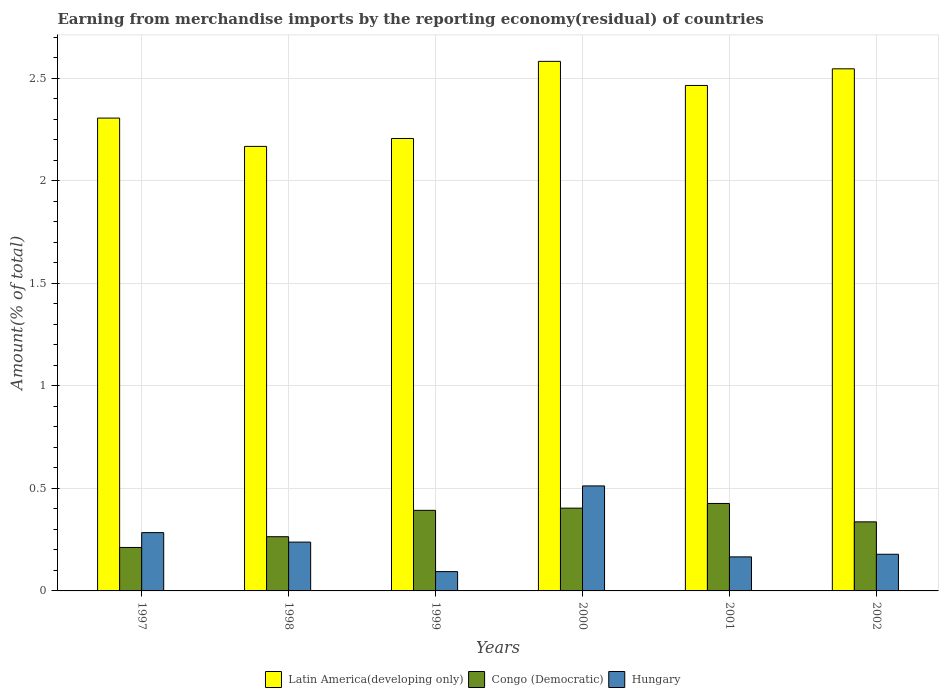How many different coloured bars are there?
Offer a very short reply. 3. How many groups of bars are there?
Make the answer very short. 6. Are the number of bars per tick equal to the number of legend labels?
Offer a very short reply. Yes. How many bars are there on the 5th tick from the left?
Your response must be concise. 3. In how many cases, is the number of bars for a given year not equal to the number of legend labels?
Your response must be concise. 0. What is the percentage of amount earned from merchandise imports in Latin America(developing only) in 1999?
Your answer should be very brief. 2.21. Across all years, what is the maximum percentage of amount earned from merchandise imports in Hungary?
Your answer should be very brief. 0.51. Across all years, what is the minimum percentage of amount earned from merchandise imports in Hungary?
Your response must be concise. 0.09. In which year was the percentage of amount earned from merchandise imports in Congo (Democratic) maximum?
Offer a terse response. 2001. What is the total percentage of amount earned from merchandise imports in Hungary in the graph?
Ensure brevity in your answer.  1.47. What is the difference between the percentage of amount earned from merchandise imports in Hungary in 1997 and that in 2000?
Provide a succinct answer. -0.23. What is the difference between the percentage of amount earned from merchandise imports in Latin America(developing only) in 2000 and the percentage of amount earned from merchandise imports in Hungary in 2001?
Your response must be concise. 2.42. What is the average percentage of amount earned from merchandise imports in Latin America(developing only) per year?
Offer a very short reply. 2.38. In the year 1998, what is the difference between the percentage of amount earned from merchandise imports in Congo (Democratic) and percentage of amount earned from merchandise imports in Hungary?
Your answer should be compact. 0.03. What is the ratio of the percentage of amount earned from merchandise imports in Congo (Democratic) in 1998 to that in 2001?
Provide a succinct answer. 0.62. What is the difference between the highest and the second highest percentage of amount earned from merchandise imports in Hungary?
Give a very brief answer. 0.23. What is the difference between the highest and the lowest percentage of amount earned from merchandise imports in Congo (Democratic)?
Offer a very short reply. 0.21. In how many years, is the percentage of amount earned from merchandise imports in Congo (Democratic) greater than the average percentage of amount earned from merchandise imports in Congo (Democratic) taken over all years?
Provide a short and direct response. 3. Is the sum of the percentage of amount earned from merchandise imports in Latin America(developing only) in 1997 and 2000 greater than the maximum percentage of amount earned from merchandise imports in Hungary across all years?
Your answer should be compact. Yes. What does the 1st bar from the left in 1999 represents?
Keep it short and to the point. Latin America(developing only). What does the 3rd bar from the right in 2001 represents?
Your answer should be compact. Latin America(developing only). How many bars are there?
Make the answer very short. 18. How many years are there in the graph?
Your answer should be very brief. 6. What is the difference between two consecutive major ticks on the Y-axis?
Make the answer very short. 0.5. Does the graph contain any zero values?
Keep it short and to the point. No. Where does the legend appear in the graph?
Your answer should be compact. Bottom center. How many legend labels are there?
Offer a terse response. 3. How are the legend labels stacked?
Your answer should be compact. Horizontal. What is the title of the graph?
Offer a very short reply. Earning from merchandise imports by the reporting economy(residual) of countries. What is the label or title of the X-axis?
Make the answer very short. Years. What is the label or title of the Y-axis?
Provide a succinct answer. Amount(% of total). What is the Amount(% of total) of Latin America(developing only) in 1997?
Offer a terse response. 2.31. What is the Amount(% of total) in Congo (Democratic) in 1997?
Provide a short and direct response. 0.21. What is the Amount(% of total) of Hungary in 1997?
Provide a succinct answer. 0.28. What is the Amount(% of total) in Latin America(developing only) in 1998?
Offer a very short reply. 2.17. What is the Amount(% of total) of Congo (Democratic) in 1998?
Offer a terse response. 0.26. What is the Amount(% of total) in Hungary in 1998?
Your answer should be compact. 0.24. What is the Amount(% of total) in Latin America(developing only) in 1999?
Offer a very short reply. 2.21. What is the Amount(% of total) of Congo (Democratic) in 1999?
Keep it short and to the point. 0.39. What is the Amount(% of total) in Hungary in 1999?
Your response must be concise. 0.09. What is the Amount(% of total) in Latin America(developing only) in 2000?
Offer a very short reply. 2.58. What is the Amount(% of total) in Congo (Democratic) in 2000?
Your response must be concise. 0.4. What is the Amount(% of total) in Hungary in 2000?
Make the answer very short. 0.51. What is the Amount(% of total) of Latin America(developing only) in 2001?
Give a very brief answer. 2.46. What is the Amount(% of total) in Congo (Democratic) in 2001?
Your answer should be compact. 0.43. What is the Amount(% of total) of Hungary in 2001?
Your response must be concise. 0.17. What is the Amount(% of total) of Latin America(developing only) in 2002?
Make the answer very short. 2.55. What is the Amount(% of total) of Congo (Democratic) in 2002?
Make the answer very short. 0.34. What is the Amount(% of total) in Hungary in 2002?
Make the answer very short. 0.18. Across all years, what is the maximum Amount(% of total) in Latin America(developing only)?
Offer a very short reply. 2.58. Across all years, what is the maximum Amount(% of total) in Congo (Democratic)?
Provide a succinct answer. 0.43. Across all years, what is the maximum Amount(% of total) of Hungary?
Provide a succinct answer. 0.51. Across all years, what is the minimum Amount(% of total) of Latin America(developing only)?
Offer a very short reply. 2.17. Across all years, what is the minimum Amount(% of total) in Congo (Democratic)?
Make the answer very short. 0.21. Across all years, what is the minimum Amount(% of total) in Hungary?
Make the answer very short. 0.09. What is the total Amount(% of total) in Latin America(developing only) in the graph?
Provide a short and direct response. 14.27. What is the total Amount(% of total) in Congo (Democratic) in the graph?
Make the answer very short. 2.04. What is the total Amount(% of total) of Hungary in the graph?
Offer a terse response. 1.47. What is the difference between the Amount(% of total) in Latin America(developing only) in 1997 and that in 1998?
Make the answer very short. 0.14. What is the difference between the Amount(% of total) of Congo (Democratic) in 1997 and that in 1998?
Your answer should be very brief. -0.05. What is the difference between the Amount(% of total) of Hungary in 1997 and that in 1998?
Your response must be concise. 0.05. What is the difference between the Amount(% of total) in Latin America(developing only) in 1997 and that in 1999?
Give a very brief answer. 0.1. What is the difference between the Amount(% of total) in Congo (Democratic) in 1997 and that in 1999?
Your answer should be compact. -0.18. What is the difference between the Amount(% of total) of Hungary in 1997 and that in 1999?
Provide a short and direct response. 0.19. What is the difference between the Amount(% of total) of Latin America(developing only) in 1997 and that in 2000?
Ensure brevity in your answer.  -0.28. What is the difference between the Amount(% of total) in Congo (Democratic) in 1997 and that in 2000?
Offer a very short reply. -0.19. What is the difference between the Amount(% of total) in Hungary in 1997 and that in 2000?
Provide a succinct answer. -0.23. What is the difference between the Amount(% of total) of Latin America(developing only) in 1997 and that in 2001?
Provide a succinct answer. -0.16. What is the difference between the Amount(% of total) in Congo (Democratic) in 1997 and that in 2001?
Provide a short and direct response. -0.21. What is the difference between the Amount(% of total) of Hungary in 1997 and that in 2001?
Offer a terse response. 0.12. What is the difference between the Amount(% of total) in Latin America(developing only) in 1997 and that in 2002?
Offer a very short reply. -0.24. What is the difference between the Amount(% of total) of Congo (Democratic) in 1997 and that in 2002?
Give a very brief answer. -0.12. What is the difference between the Amount(% of total) in Hungary in 1997 and that in 2002?
Your response must be concise. 0.11. What is the difference between the Amount(% of total) of Latin America(developing only) in 1998 and that in 1999?
Provide a short and direct response. -0.04. What is the difference between the Amount(% of total) in Congo (Democratic) in 1998 and that in 1999?
Provide a short and direct response. -0.13. What is the difference between the Amount(% of total) in Hungary in 1998 and that in 1999?
Give a very brief answer. 0.14. What is the difference between the Amount(% of total) of Latin America(developing only) in 1998 and that in 2000?
Offer a very short reply. -0.41. What is the difference between the Amount(% of total) of Congo (Democratic) in 1998 and that in 2000?
Your answer should be compact. -0.14. What is the difference between the Amount(% of total) of Hungary in 1998 and that in 2000?
Your response must be concise. -0.27. What is the difference between the Amount(% of total) of Latin America(developing only) in 1998 and that in 2001?
Ensure brevity in your answer.  -0.3. What is the difference between the Amount(% of total) of Congo (Democratic) in 1998 and that in 2001?
Your answer should be compact. -0.16. What is the difference between the Amount(% of total) of Hungary in 1998 and that in 2001?
Provide a short and direct response. 0.07. What is the difference between the Amount(% of total) in Latin America(developing only) in 1998 and that in 2002?
Offer a terse response. -0.38. What is the difference between the Amount(% of total) in Congo (Democratic) in 1998 and that in 2002?
Your answer should be compact. -0.07. What is the difference between the Amount(% of total) of Hungary in 1998 and that in 2002?
Make the answer very short. 0.06. What is the difference between the Amount(% of total) in Latin America(developing only) in 1999 and that in 2000?
Your answer should be very brief. -0.38. What is the difference between the Amount(% of total) of Congo (Democratic) in 1999 and that in 2000?
Ensure brevity in your answer.  -0.01. What is the difference between the Amount(% of total) in Hungary in 1999 and that in 2000?
Keep it short and to the point. -0.42. What is the difference between the Amount(% of total) in Latin America(developing only) in 1999 and that in 2001?
Make the answer very short. -0.26. What is the difference between the Amount(% of total) in Congo (Democratic) in 1999 and that in 2001?
Give a very brief answer. -0.03. What is the difference between the Amount(% of total) in Hungary in 1999 and that in 2001?
Make the answer very short. -0.07. What is the difference between the Amount(% of total) of Latin America(developing only) in 1999 and that in 2002?
Your answer should be very brief. -0.34. What is the difference between the Amount(% of total) in Congo (Democratic) in 1999 and that in 2002?
Keep it short and to the point. 0.06. What is the difference between the Amount(% of total) in Hungary in 1999 and that in 2002?
Keep it short and to the point. -0.08. What is the difference between the Amount(% of total) in Latin America(developing only) in 2000 and that in 2001?
Your answer should be compact. 0.12. What is the difference between the Amount(% of total) of Congo (Democratic) in 2000 and that in 2001?
Your response must be concise. -0.02. What is the difference between the Amount(% of total) in Hungary in 2000 and that in 2001?
Offer a terse response. 0.35. What is the difference between the Amount(% of total) of Latin America(developing only) in 2000 and that in 2002?
Provide a succinct answer. 0.04. What is the difference between the Amount(% of total) of Congo (Democratic) in 2000 and that in 2002?
Give a very brief answer. 0.07. What is the difference between the Amount(% of total) of Hungary in 2000 and that in 2002?
Keep it short and to the point. 0.33. What is the difference between the Amount(% of total) in Latin America(developing only) in 2001 and that in 2002?
Keep it short and to the point. -0.08. What is the difference between the Amount(% of total) in Congo (Democratic) in 2001 and that in 2002?
Keep it short and to the point. 0.09. What is the difference between the Amount(% of total) of Hungary in 2001 and that in 2002?
Your response must be concise. -0.01. What is the difference between the Amount(% of total) of Latin America(developing only) in 1997 and the Amount(% of total) of Congo (Democratic) in 1998?
Offer a very short reply. 2.04. What is the difference between the Amount(% of total) in Latin America(developing only) in 1997 and the Amount(% of total) in Hungary in 1998?
Your answer should be compact. 2.07. What is the difference between the Amount(% of total) of Congo (Democratic) in 1997 and the Amount(% of total) of Hungary in 1998?
Offer a very short reply. -0.03. What is the difference between the Amount(% of total) in Latin America(developing only) in 1997 and the Amount(% of total) in Congo (Democratic) in 1999?
Your answer should be very brief. 1.91. What is the difference between the Amount(% of total) in Latin America(developing only) in 1997 and the Amount(% of total) in Hungary in 1999?
Your response must be concise. 2.21. What is the difference between the Amount(% of total) of Congo (Democratic) in 1997 and the Amount(% of total) of Hungary in 1999?
Ensure brevity in your answer.  0.12. What is the difference between the Amount(% of total) of Latin America(developing only) in 1997 and the Amount(% of total) of Congo (Democratic) in 2000?
Keep it short and to the point. 1.9. What is the difference between the Amount(% of total) in Latin America(developing only) in 1997 and the Amount(% of total) in Hungary in 2000?
Your response must be concise. 1.79. What is the difference between the Amount(% of total) in Latin America(developing only) in 1997 and the Amount(% of total) in Congo (Democratic) in 2001?
Your answer should be compact. 1.88. What is the difference between the Amount(% of total) in Latin America(developing only) in 1997 and the Amount(% of total) in Hungary in 2001?
Provide a succinct answer. 2.14. What is the difference between the Amount(% of total) in Congo (Democratic) in 1997 and the Amount(% of total) in Hungary in 2001?
Your answer should be very brief. 0.05. What is the difference between the Amount(% of total) of Latin America(developing only) in 1997 and the Amount(% of total) of Congo (Democratic) in 2002?
Your response must be concise. 1.97. What is the difference between the Amount(% of total) in Latin America(developing only) in 1997 and the Amount(% of total) in Hungary in 2002?
Offer a very short reply. 2.13. What is the difference between the Amount(% of total) in Congo (Democratic) in 1997 and the Amount(% of total) in Hungary in 2002?
Your answer should be very brief. 0.03. What is the difference between the Amount(% of total) in Latin America(developing only) in 1998 and the Amount(% of total) in Congo (Democratic) in 1999?
Give a very brief answer. 1.77. What is the difference between the Amount(% of total) of Latin America(developing only) in 1998 and the Amount(% of total) of Hungary in 1999?
Offer a very short reply. 2.07. What is the difference between the Amount(% of total) in Congo (Democratic) in 1998 and the Amount(% of total) in Hungary in 1999?
Offer a very short reply. 0.17. What is the difference between the Amount(% of total) in Latin America(developing only) in 1998 and the Amount(% of total) in Congo (Democratic) in 2000?
Your response must be concise. 1.76. What is the difference between the Amount(% of total) of Latin America(developing only) in 1998 and the Amount(% of total) of Hungary in 2000?
Your response must be concise. 1.66. What is the difference between the Amount(% of total) in Congo (Democratic) in 1998 and the Amount(% of total) in Hungary in 2000?
Your answer should be compact. -0.25. What is the difference between the Amount(% of total) in Latin America(developing only) in 1998 and the Amount(% of total) in Congo (Democratic) in 2001?
Offer a very short reply. 1.74. What is the difference between the Amount(% of total) of Latin America(developing only) in 1998 and the Amount(% of total) of Hungary in 2001?
Make the answer very short. 2. What is the difference between the Amount(% of total) in Congo (Democratic) in 1998 and the Amount(% of total) in Hungary in 2001?
Your response must be concise. 0.1. What is the difference between the Amount(% of total) in Latin America(developing only) in 1998 and the Amount(% of total) in Congo (Democratic) in 2002?
Keep it short and to the point. 1.83. What is the difference between the Amount(% of total) of Latin America(developing only) in 1998 and the Amount(% of total) of Hungary in 2002?
Make the answer very short. 1.99. What is the difference between the Amount(% of total) in Congo (Democratic) in 1998 and the Amount(% of total) in Hungary in 2002?
Provide a succinct answer. 0.09. What is the difference between the Amount(% of total) in Latin America(developing only) in 1999 and the Amount(% of total) in Congo (Democratic) in 2000?
Your response must be concise. 1.8. What is the difference between the Amount(% of total) of Latin America(developing only) in 1999 and the Amount(% of total) of Hungary in 2000?
Your answer should be very brief. 1.69. What is the difference between the Amount(% of total) in Congo (Democratic) in 1999 and the Amount(% of total) in Hungary in 2000?
Your answer should be compact. -0.12. What is the difference between the Amount(% of total) of Latin America(developing only) in 1999 and the Amount(% of total) of Congo (Democratic) in 2001?
Offer a very short reply. 1.78. What is the difference between the Amount(% of total) in Latin America(developing only) in 1999 and the Amount(% of total) in Hungary in 2001?
Your response must be concise. 2.04. What is the difference between the Amount(% of total) in Congo (Democratic) in 1999 and the Amount(% of total) in Hungary in 2001?
Keep it short and to the point. 0.23. What is the difference between the Amount(% of total) in Latin America(developing only) in 1999 and the Amount(% of total) in Congo (Democratic) in 2002?
Provide a short and direct response. 1.87. What is the difference between the Amount(% of total) in Latin America(developing only) in 1999 and the Amount(% of total) in Hungary in 2002?
Offer a very short reply. 2.03. What is the difference between the Amount(% of total) in Congo (Democratic) in 1999 and the Amount(% of total) in Hungary in 2002?
Offer a terse response. 0.21. What is the difference between the Amount(% of total) of Latin America(developing only) in 2000 and the Amount(% of total) of Congo (Democratic) in 2001?
Your answer should be compact. 2.16. What is the difference between the Amount(% of total) of Latin America(developing only) in 2000 and the Amount(% of total) of Hungary in 2001?
Your answer should be very brief. 2.42. What is the difference between the Amount(% of total) in Congo (Democratic) in 2000 and the Amount(% of total) in Hungary in 2001?
Provide a succinct answer. 0.24. What is the difference between the Amount(% of total) in Latin America(developing only) in 2000 and the Amount(% of total) in Congo (Democratic) in 2002?
Ensure brevity in your answer.  2.25. What is the difference between the Amount(% of total) of Latin America(developing only) in 2000 and the Amount(% of total) of Hungary in 2002?
Provide a short and direct response. 2.4. What is the difference between the Amount(% of total) in Congo (Democratic) in 2000 and the Amount(% of total) in Hungary in 2002?
Make the answer very short. 0.22. What is the difference between the Amount(% of total) in Latin America(developing only) in 2001 and the Amount(% of total) in Congo (Democratic) in 2002?
Your answer should be very brief. 2.13. What is the difference between the Amount(% of total) in Latin America(developing only) in 2001 and the Amount(% of total) in Hungary in 2002?
Your answer should be compact. 2.29. What is the difference between the Amount(% of total) in Congo (Democratic) in 2001 and the Amount(% of total) in Hungary in 2002?
Your answer should be very brief. 0.25. What is the average Amount(% of total) in Latin America(developing only) per year?
Make the answer very short. 2.38. What is the average Amount(% of total) in Congo (Democratic) per year?
Your response must be concise. 0.34. What is the average Amount(% of total) of Hungary per year?
Give a very brief answer. 0.25. In the year 1997, what is the difference between the Amount(% of total) of Latin America(developing only) and Amount(% of total) of Congo (Democratic)?
Keep it short and to the point. 2.09. In the year 1997, what is the difference between the Amount(% of total) in Latin America(developing only) and Amount(% of total) in Hungary?
Ensure brevity in your answer.  2.02. In the year 1997, what is the difference between the Amount(% of total) in Congo (Democratic) and Amount(% of total) in Hungary?
Offer a terse response. -0.07. In the year 1998, what is the difference between the Amount(% of total) of Latin America(developing only) and Amount(% of total) of Congo (Democratic)?
Provide a short and direct response. 1.9. In the year 1998, what is the difference between the Amount(% of total) of Latin America(developing only) and Amount(% of total) of Hungary?
Provide a short and direct response. 1.93. In the year 1998, what is the difference between the Amount(% of total) in Congo (Democratic) and Amount(% of total) in Hungary?
Give a very brief answer. 0.03. In the year 1999, what is the difference between the Amount(% of total) in Latin America(developing only) and Amount(% of total) in Congo (Democratic)?
Your answer should be very brief. 1.81. In the year 1999, what is the difference between the Amount(% of total) of Latin America(developing only) and Amount(% of total) of Hungary?
Give a very brief answer. 2.11. In the year 1999, what is the difference between the Amount(% of total) in Congo (Democratic) and Amount(% of total) in Hungary?
Make the answer very short. 0.3. In the year 2000, what is the difference between the Amount(% of total) of Latin America(developing only) and Amount(% of total) of Congo (Democratic)?
Give a very brief answer. 2.18. In the year 2000, what is the difference between the Amount(% of total) of Latin America(developing only) and Amount(% of total) of Hungary?
Ensure brevity in your answer.  2.07. In the year 2000, what is the difference between the Amount(% of total) in Congo (Democratic) and Amount(% of total) in Hungary?
Ensure brevity in your answer.  -0.11. In the year 2001, what is the difference between the Amount(% of total) in Latin America(developing only) and Amount(% of total) in Congo (Democratic)?
Your answer should be very brief. 2.04. In the year 2001, what is the difference between the Amount(% of total) in Latin America(developing only) and Amount(% of total) in Hungary?
Make the answer very short. 2.3. In the year 2001, what is the difference between the Amount(% of total) of Congo (Democratic) and Amount(% of total) of Hungary?
Ensure brevity in your answer.  0.26. In the year 2002, what is the difference between the Amount(% of total) in Latin America(developing only) and Amount(% of total) in Congo (Democratic)?
Offer a terse response. 2.21. In the year 2002, what is the difference between the Amount(% of total) in Latin America(developing only) and Amount(% of total) in Hungary?
Offer a very short reply. 2.37. In the year 2002, what is the difference between the Amount(% of total) of Congo (Democratic) and Amount(% of total) of Hungary?
Keep it short and to the point. 0.16. What is the ratio of the Amount(% of total) of Latin America(developing only) in 1997 to that in 1998?
Ensure brevity in your answer.  1.06. What is the ratio of the Amount(% of total) of Congo (Democratic) in 1997 to that in 1998?
Your answer should be compact. 0.8. What is the ratio of the Amount(% of total) of Hungary in 1997 to that in 1998?
Ensure brevity in your answer.  1.19. What is the ratio of the Amount(% of total) of Latin America(developing only) in 1997 to that in 1999?
Offer a terse response. 1.05. What is the ratio of the Amount(% of total) in Congo (Democratic) in 1997 to that in 1999?
Your response must be concise. 0.54. What is the ratio of the Amount(% of total) in Hungary in 1997 to that in 1999?
Your answer should be compact. 3.02. What is the ratio of the Amount(% of total) of Latin America(developing only) in 1997 to that in 2000?
Your response must be concise. 0.89. What is the ratio of the Amount(% of total) in Congo (Democratic) in 1997 to that in 2000?
Ensure brevity in your answer.  0.53. What is the ratio of the Amount(% of total) of Hungary in 1997 to that in 2000?
Keep it short and to the point. 0.56. What is the ratio of the Amount(% of total) in Latin America(developing only) in 1997 to that in 2001?
Offer a very short reply. 0.94. What is the ratio of the Amount(% of total) of Congo (Democratic) in 1997 to that in 2001?
Your answer should be compact. 0.5. What is the ratio of the Amount(% of total) in Hungary in 1997 to that in 2001?
Your response must be concise. 1.71. What is the ratio of the Amount(% of total) of Latin America(developing only) in 1997 to that in 2002?
Your answer should be very brief. 0.91. What is the ratio of the Amount(% of total) in Congo (Democratic) in 1997 to that in 2002?
Offer a terse response. 0.63. What is the ratio of the Amount(% of total) of Hungary in 1997 to that in 2002?
Ensure brevity in your answer.  1.59. What is the ratio of the Amount(% of total) of Latin America(developing only) in 1998 to that in 1999?
Offer a terse response. 0.98. What is the ratio of the Amount(% of total) in Congo (Democratic) in 1998 to that in 1999?
Provide a short and direct response. 0.67. What is the ratio of the Amount(% of total) of Hungary in 1998 to that in 1999?
Offer a terse response. 2.53. What is the ratio of the Amount(% of total) of Latin America(developing only) in 1998 to that in 2000?
Your answer should be very brief. 0.84. What is the ratio of the Amount(% of total) of Congo (Democratic) in 1998 to that in 2000?
Make the answer very short. 0.65. What is the ratio of the Amount(% of total) of Hungary in 1998 to that in 2000?
Offer a very short reply. 0.47. What is the ratio of the Amount(% of total) in Latin America(developing only) in 1998 to that in 2001?
Offer a terse response. 0.88. What is the ratio of the Amount(% of total) in Congo (Democratic) in 1998 to that in 2001?
Offer a terse response. 0.62. What is the ratio of the Amount(% of total) in Hungary in 1998 to that in 2001?
Offer a terse response. 1.43. What is the ratio of the Amount(% of total) of Latin America(developing only) in 1998 to that in 2002?
Provide a short and direct response. 0.85. What is the ratio of the Amount(% of total) in Congo (Democratic) in 1998 to that in 2002?
Offer a very short reply. 0.78. What is the ratio of the Amount(% of total) of Hungary in 1998 to that in 2002?
Provide a succinct answer. 1.33. What is the ratio of the Amount(% of total) in Latin America(developing only) in 1999 to that in 2000?
Ensure brevity in your answer.  0.85. What is the ratio of the Amount(% of total) of Congo (Democratic) in 1999 to that in 2000?
Ensure brevity in your answer.  0.97. What is the ratio of the Amount(% of total) of Hungary in 1999 to that in 2000?
Offer a terse response. 0.18. What is the ratio of the Amount(% of total) of Latin America(developing only) in 1999 to that in 2001?
Keep it short and to the point. 0.9. What is the ratio of the Amount(% of total) in Congo (Democratic) in 1999 to that in 2001?
Your answer should be very brief. 0.92. What is the ratio of the Amount(% of total) of Hungary in 1999 to that in 2001?
Give a very brief answer. 0.57. What is the ratio of the Amount(% of total) of Latin America(developing only) in 1999 to that in 2002?
Your answer should be compact. 0.87. What is the ratio of the Amount(% of total) of Hungary in 1999 to that in 2002?
Ensure brevity in your answer.  0.53. What is the ratio of the Amount(% of total) of Latin America(developing only) in 2000 to that in 2001?
Provide a succinct answer. 1.05. What is the ratio of the Amount(% of total) in Congo (Democratic) in 2000 to that in 2001?
Keep it short and to the point. 0.95. What is the ratio of the Amount(% of total) of Hungary in 2000 to that in 2001?
Provide a short and direct response. 3.08. What is the ratio of the Amount(% of total) in Latin America(developing only) in 2000 to that in 2002?
Provide a succinct answer. 1.01. What is the ratio of the Amount(% of total) in Congo (Democratic) in 2000 to that in 2002?
Make the answer very short. 1.2. What is the ratio of the Amount(% of total) in Hungary in 2000 to that in 2002?
Offer a terse response. 2.86. What is the ratio of the Amount(% of total) in Latin America(developing only) in 2001 to that in 2002?
Your response must be concise. 0.97. What is the ratio of the Amount(% of total) in Congo (Democratic) in 2001 to that in 2002?
Offer a very short reply. 1.27. What is the ratio of the Amount(% of total) of Hungary in 2001 to that in 2002?
Ensure brevity in your answer.  0.93. What is the difference between the highest and the second highest Amount(% of total) in Latin America(developing only)?
Your answer should be very brief. 0.04. What is the difference between the highest and the second highest Amount(% of total) of Congo (Democratic)?
Ensure brevity in your answer.  0.02. What is the difference between the highest and the second highest Amount(% of total) in Hungary?
Your answer should be very brief. 0.23. What is the difference between the highest and the lowest Amount(% of total) of Latin America(developing only)?
Make the answer very short. 0.41. What is the difference between the highest and the lowest Amount(% of total) in Congo (Democratic)?
Make the answer very short. 0.21. What is the difference between the highest and the lowest Amount(% of total) in Hungary?
Give a very brief answer. 0.42. 